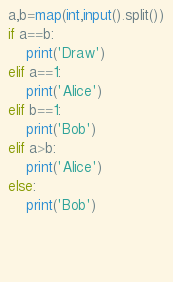<code> <loc_0><loc_0><loc_500><loc_500><_Python_>a,b=map(int,input().split())
if a==b:
	print('Draw')
elif a==1:
	print('Alice')
elif b==1:
	print('Bob')
elif a>b:
	print('Alice')
else:
	print('Bob')	
	
	
	
</code> 